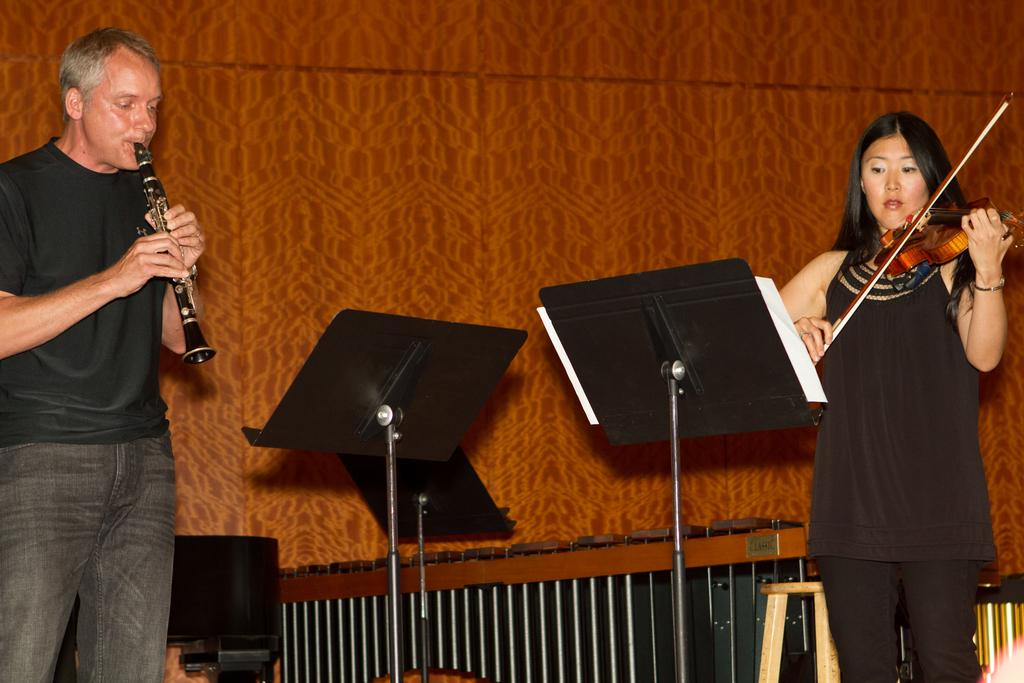How many people are in the image? There are two people in the image. What are the people doing in the image? Both people are standing. What is the woman holding in her hand? The woman is holding a violin in her hand. What is the man holding in the image? The man is holding a musical instrument. Where is the playground located in the image? There is no playground present in the image. What type of needle is the woman using to play the violin in the image? The woman is not using a needle to play the violin; she is holding a violin in her hand. 